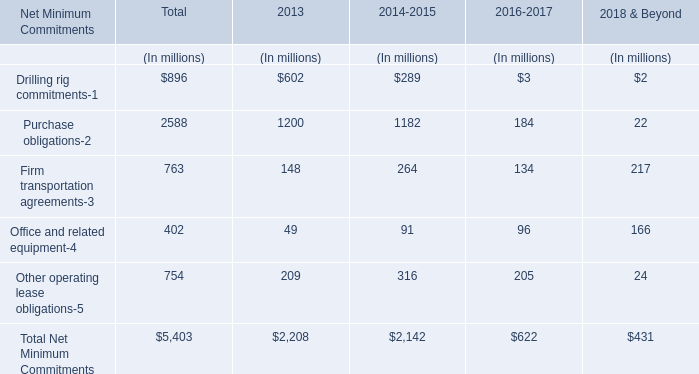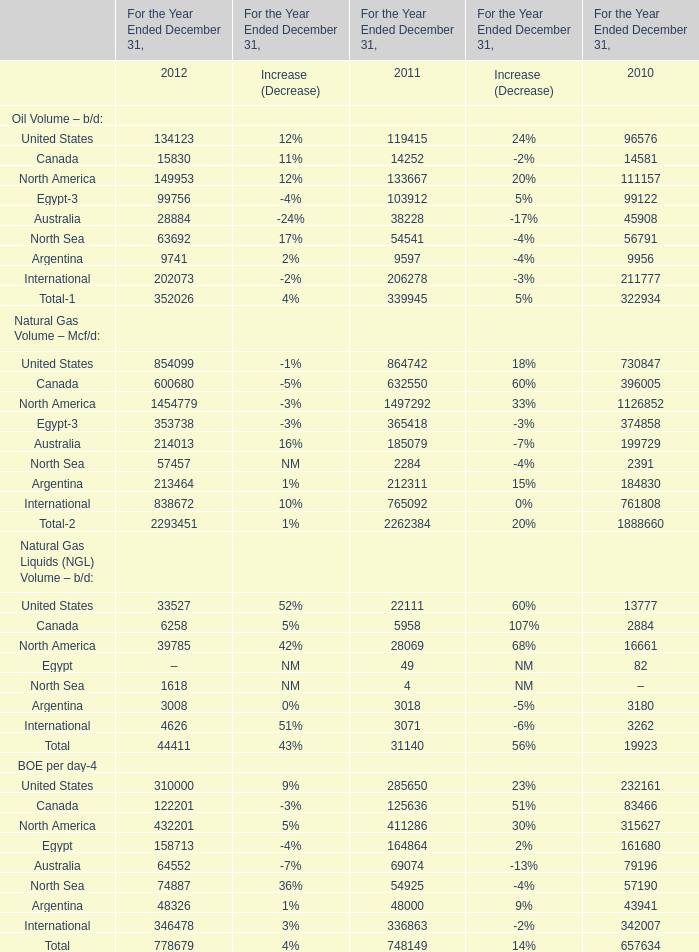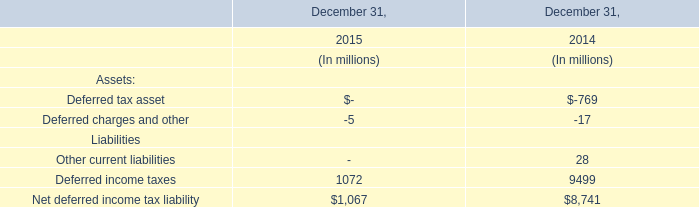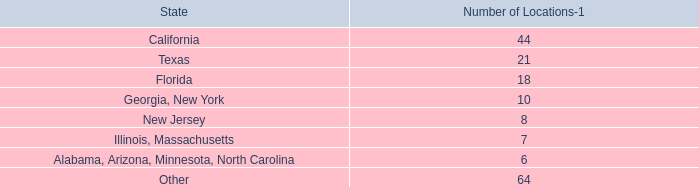What's the total amount of the oil volum in the years where North Sea is greater than 60000? (in b/d) 
Computations: ((((((134123 + 15830) + 149953) + 99756) + 28884) + 63692) + 9741)
Answer: 501979.0. 